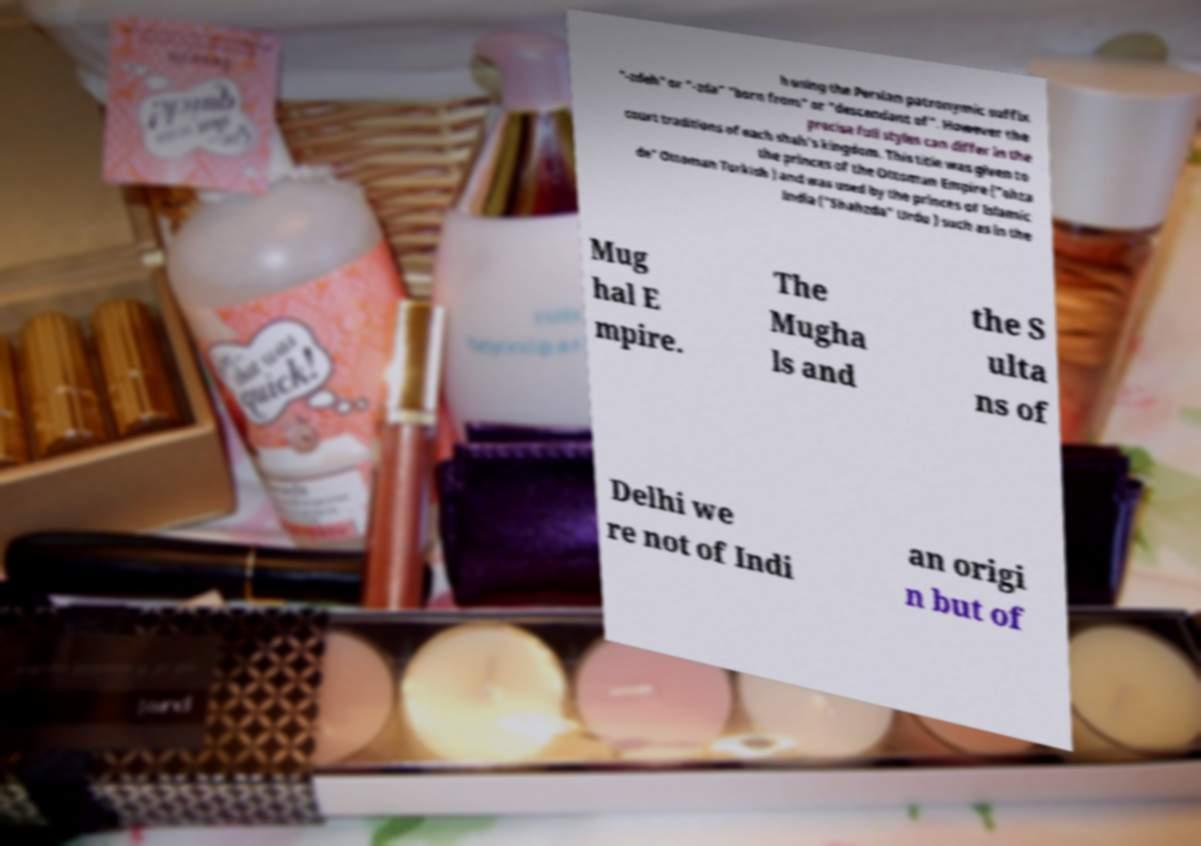Please read and relay the text visible in this image. What does it say? h using the Persian patronymic suffix "-zdeh" or "-zda" "born from" or "descendant of". However the precise full styles can differ in the court traditions of each shah's kingdom. This title was given to the princes of the Ottoman Empire ("ehza de" Ottoman Turkish ) and was used by the princes of Islamic India ("Shahzda" Urdu ) such as in the Mug hal E mpire. The Mugha ls and the S ulta ns of Delhi we re not of Indi an origi n but of 